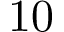Convert formula to latex. <formula><loc_0><loc_0><loc_500><loc_500>1 0</formula> 